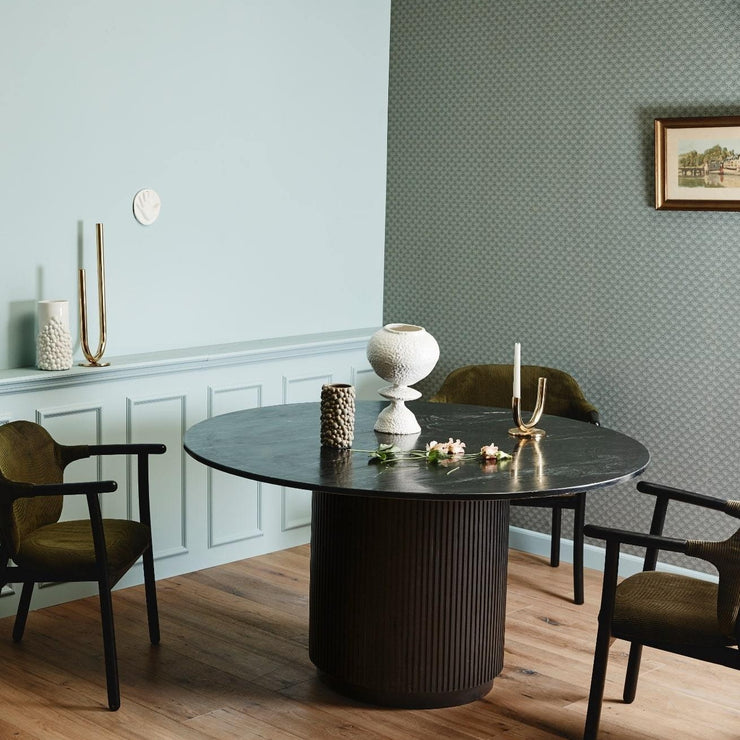What style of decor is represented in this room? The room depicts a modern minimalist style with a touch of mid-century influence, characterized by the clean lines of the furniture, the simple yet elegant table centerpiece, and the subtle use of color and patterns in the decor. 